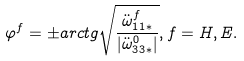Convert formula to latex. <formula><loc_0><loc_0><loc_500><loc_500>\varphi ^ { f } = \pm a r c t g \sqrt { \frac { \ddot { \omega } _ { 1 1 * } ^ { f } } { | \ddot { \omega } ^ { 0 } _ { 3 3 * } | } } , f = H , E .</formula> 